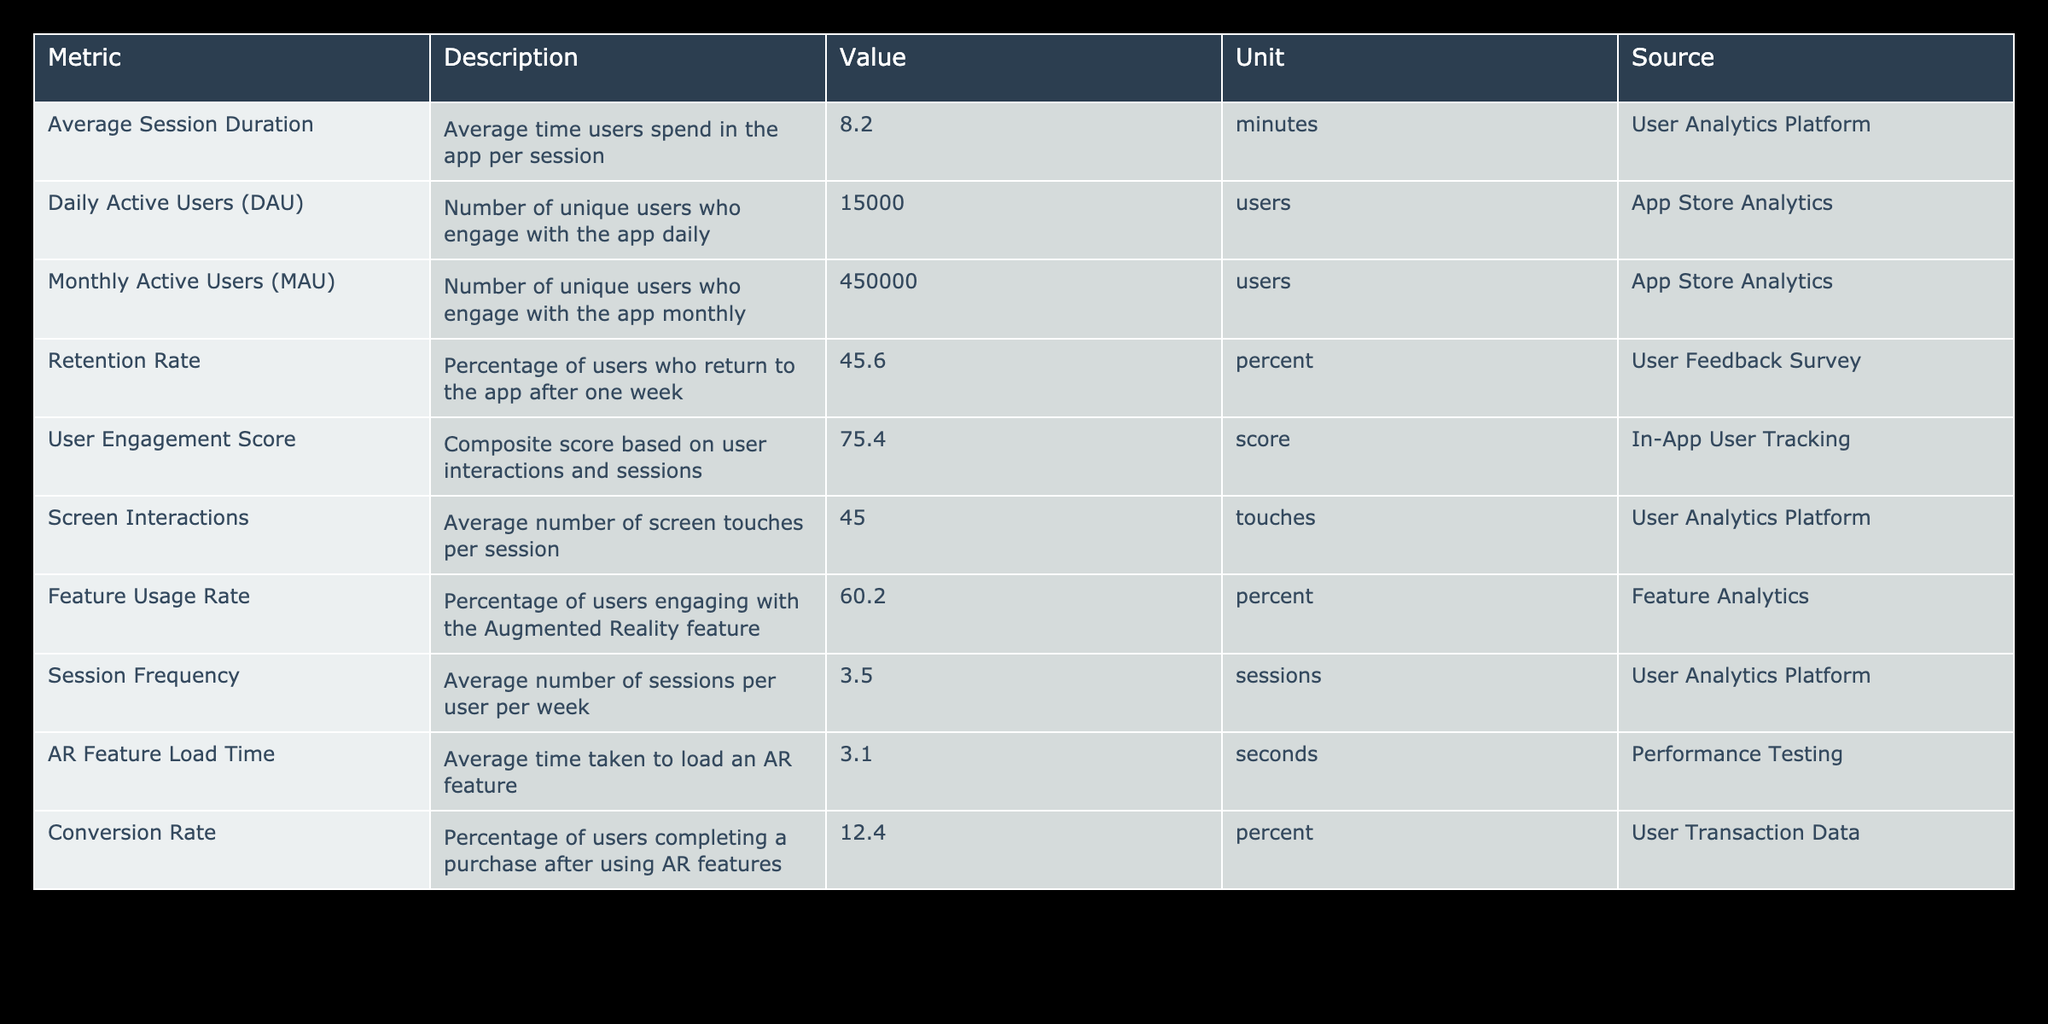What is the average session duration for users? The table lists "Average Session Duration" with a value of 8.2 minutes. This is a direct retrieval from the table.
Answer: 8.2 minutes How many daily active users does the application have? According to the table, "Daily Active Users (DAU)" is reported as 15000 users. This is mentioned directly in the table's values.
Answer: 15000 users What is the retention rate after one week? The table specifies the "Retention Rate" as 45.6 percent. This information is directly extracted from the table.
Answer: 45.6 percent What is the average number of sessions per user per week? "Session Frequency" in the table indicates an average of 3.5 sessions per user per week. This value can be retrieved straightforwardly from the table.
Answer: 3.5 sessions Is the conversion rate after using AR features greater than 10 percent? The "Conversion Rate" is 12.4 percent according to the table, which is greater than 10 percent. This is a yes/no question that can be answered directly.
Answer: Yes What percentage of users engage with the Augmented Reality feature? The table states that the "Feature Usage Rate" is 60.2 percent, directly answering the question.
Answer: 60.2 percent What is the average time taken to load an AR feature? The "AR Feature Load Time" is documented in the table as 3.1 seconds. This is a simple retrieval from the data presented.
Answer: 3.1 seconds If the average session duration increased by 2 minutes, what would its new average be? We start with the current average session duration of 8.2 minutes. Adding 2 minutes gives us 8.2 + 2 = 10.2 minutes. Thus, the new average session duration would be 10.2 minutes.
Answer: 10.2 minutes What is the difference in the number of Monthly Active Users and Daily Active Users? The table shows 450000 Monthly Active Users and 15000 Daily Active Users. To find the difference, we calculate 450000 - 15000 = 435000 users.
Answer: 435000 users How does the User Engagement Score relate to the Retention Rate in this data? The User Engagement Score is 75.4 and the Retention Rate is 45.6 percent. While both metrics indicate user involvement, there is no direct numerical comparison made in the table. However, generally, a higher User Engagement Score may correlate with a higher Retention Rate, suggesting engaged users might return more often. So, while precise relational data isn't provided, the scores suggest positive engagement and retention trends.
Answer: Higher engagement could imply better retention 